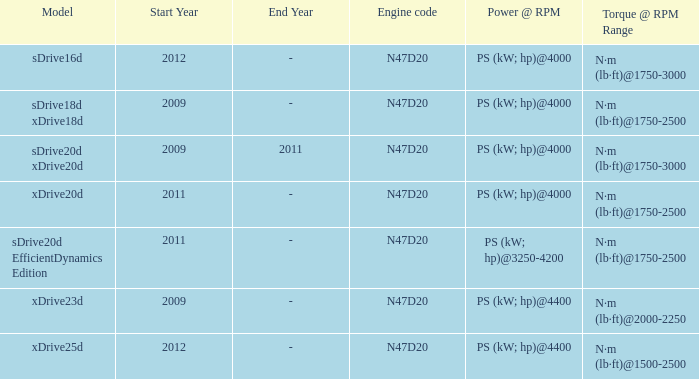What is the torque of the xdrive20d model, which has a power of ps (kw; hp)@4000? N·m (lb·ft)@1750-2500. 